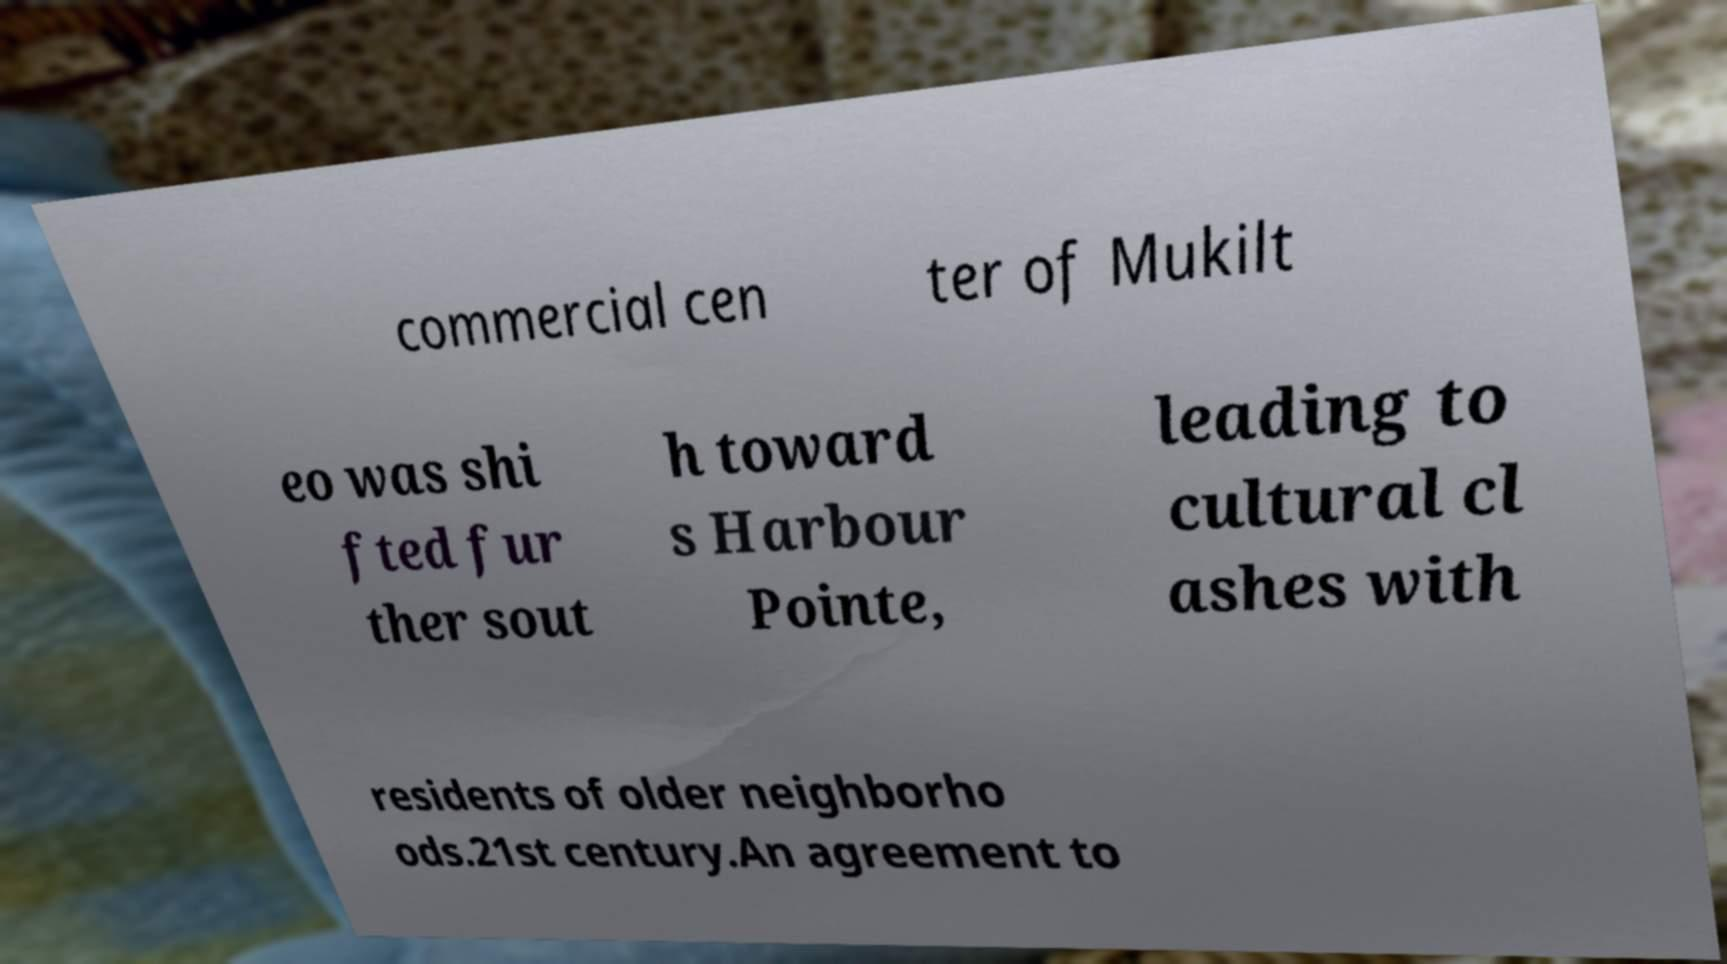There's text embedded in this image that I need extracted. Can you transcribe it verbatim? commercial cen ter of Mukilt eo was shi fted fur ther sout h toward s Harbour Pointe, leading to cultural cl ashes with residents of older neighborho ods.21st century.An agreement to 